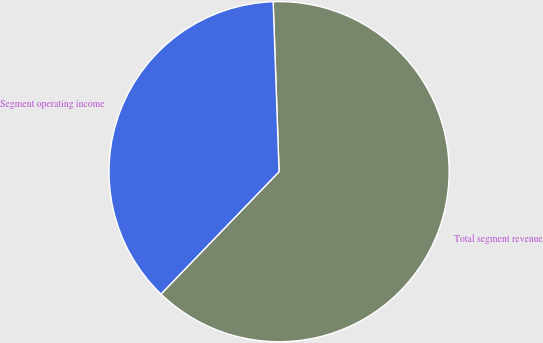Convert chart to OTSL. <chart><loc_0><loc_0><loc_500><loc_500><pie_chart><fcel>Total segment revenue<fcel>Segment operating income<nl><fcel>62.77%<fcel>37.23%<nl></chart> 